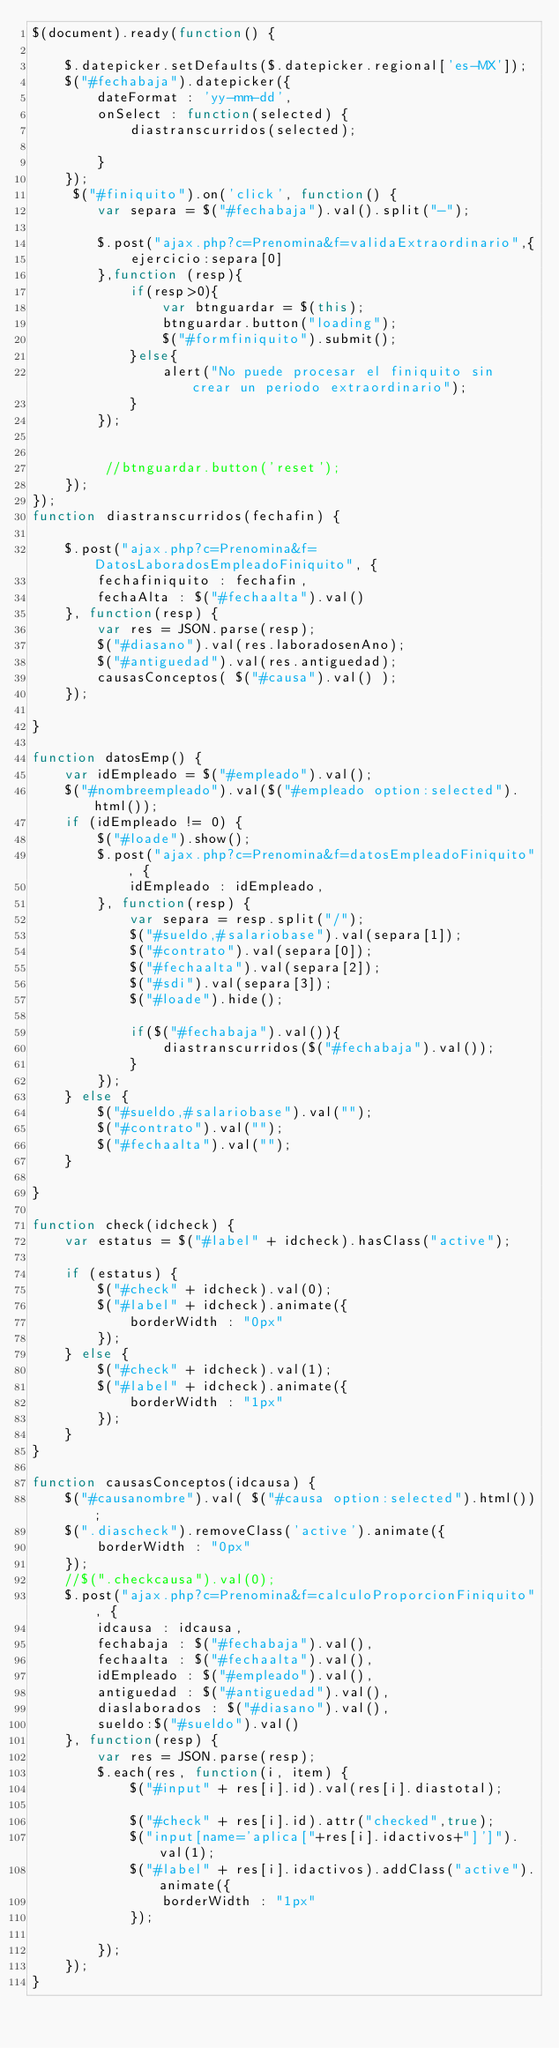Convert code to text. <code><loc_0><loc_0><loc_500><loc_500><_JavaScript_>$(document).ready(function() {

	$.datepicker.setDefaults($.datepicker.regional['es-MX']);
	$("#fechabaja").datepicker({
		dateFormat : 'yy-mm-dd',
		onSelect : function(selected) {
			diastranscurridos(selected);
			
		}
	});
	 $("#finiquito").on('click', function() {
		var separa = $("#fechabaja").val().split("-");
		
		$.post("ajax.php?c=Prenomina&f=validaExtraordinario",{
			ejercicio:separa[0]
		},function (resp){
			if(resp>0){
				var btnguardar = $(this);
 				btnguardar.button("loading");
 				$("#formfiniquito").submit();
			}else{
				alert("No puede procesar el finiquito sin crear un periodo extraordinario");
			}
		});
		
      	
		 //btnguardar.button('reset');
	});
});
function diastranscurridos(fechafin) {

	$.post("ajax.php?c=Prenomina&f=DatosLaboradosEmpleadoFiniquito", {
		fechafiniquito : fechafin,
		fechaAlta : $("#fechaalta").val()
	}, function(resp) {
		var res = JSON.parse(resp);
		$("#diasano").val(res.laboradosenAno);
		$("#antiguedad").val(res.antiguedad);
		causasConceptos( $("#causa").val() );
	});
	
}

function datosEmp() {
	var idEmpleado = $("#empleado").val();
	$("#nombreempleado").val($("#empleado option:selected").html());
	if (idEmpleado != 0) {
		$("#loade").show();
		$.post("ajax.php?c=Prenomina&f=datosEmpleadoFiniquito", {
			idEmpleado : idEmpleado,
		}, function(resp) {
			var separa = resp.split("/");
			$("#sueldo,#salariobase").val(separa[1]);
			$("#contrato").val(separa[0]);
			$("#fechaalta").val(separa[2]);
			$("#sdi").val(separa[3]);
			$("#loade").hide();
			
			if($("#fechabaja").val()){
				diastranscurridos($("#fechabaja").val());
			}
		});
	} else {
		$("#sueldo,#salariobase").val("");
		$("#contrato").val("");
		$("#fechaalta").val("");
	}
	
}

function check(idcheck) {
	var estatus = $("#label" + idcheck).hasClass("active");
	
	if (estatus) {
		$("#check" + idcheck).val(0);
		$("#label" + idcheck).animate({
			borderWidth : "0px"
		});
	} else {
		$("#check" + idcheck).val(1);
		$("#label" + idcheck).animate({
			borderWidth : "1px"
		});
	}
}

function causasConceptos(idcausa) {
	$("#causanombre").val( $("#causa option:selected").html());
	$(".diascheck").removeClass('active').animate({
		borderWidth : "0px"
	});
	//$(".checkcausa").val(0);
	$.post("ajax.php?c=Prenomina&f=calculoProporcionFiniquito", {
		idcausa : idcausa,
		fechabaja : $("#fechabaja").val(),
		fechaalta : $("#fechaalta").val(),
		idEmpleado : $("#empleado").val(),
		antiguedad : $("#antiguedad").val(),
		diaslaborados : $("#diasano").val(),
		sueldo:$("#sueldo").val()
	}, function(resp) {
		var res = JSON.parse(resp); 
		$.each(res, function(i, item) {
			$("#input" + res[i].id).val(res[i].diastotal);
			
			$("#check" + res[i].id).attr("checked",true);
			$("input[name='aplica["+res[i].idactivos+"]']").val(1);
			$("#label" + res[i].idactivos).addClass("active").animate({
				borderWidth : "1px"
			});
			
		});
	});
}


</code> 